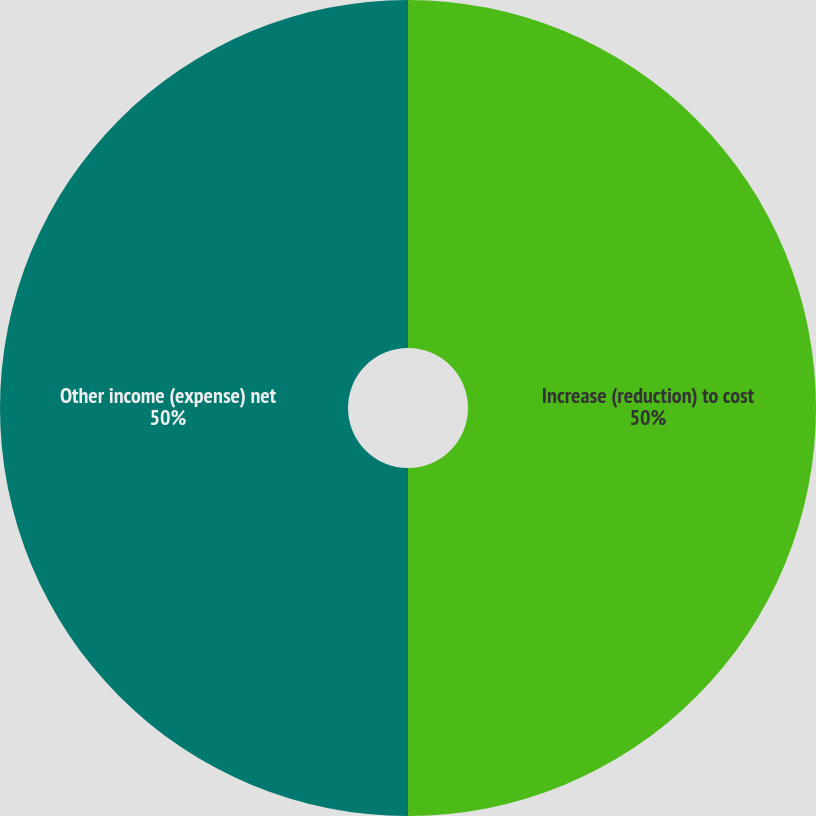Convert chart. <chart><loc_0><loc_0><loc_500><loc_500><pie_chart><fcel>Increase (reduction) to cost<fcel>Other income (expense) net<nl><fcel>50.0%<fcel>50.0%<nl></chart> 